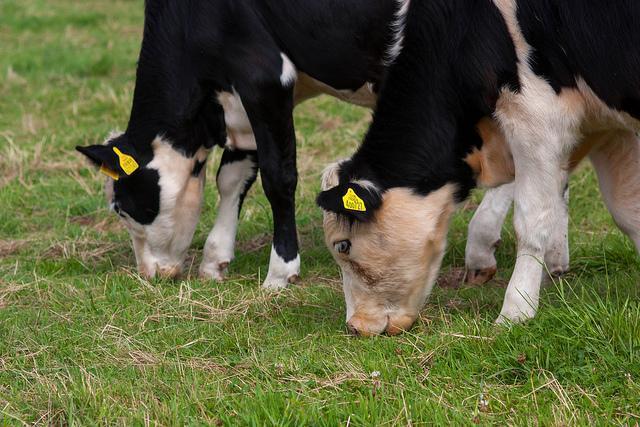How many cows are there?
Give a very brief answer. 2. 